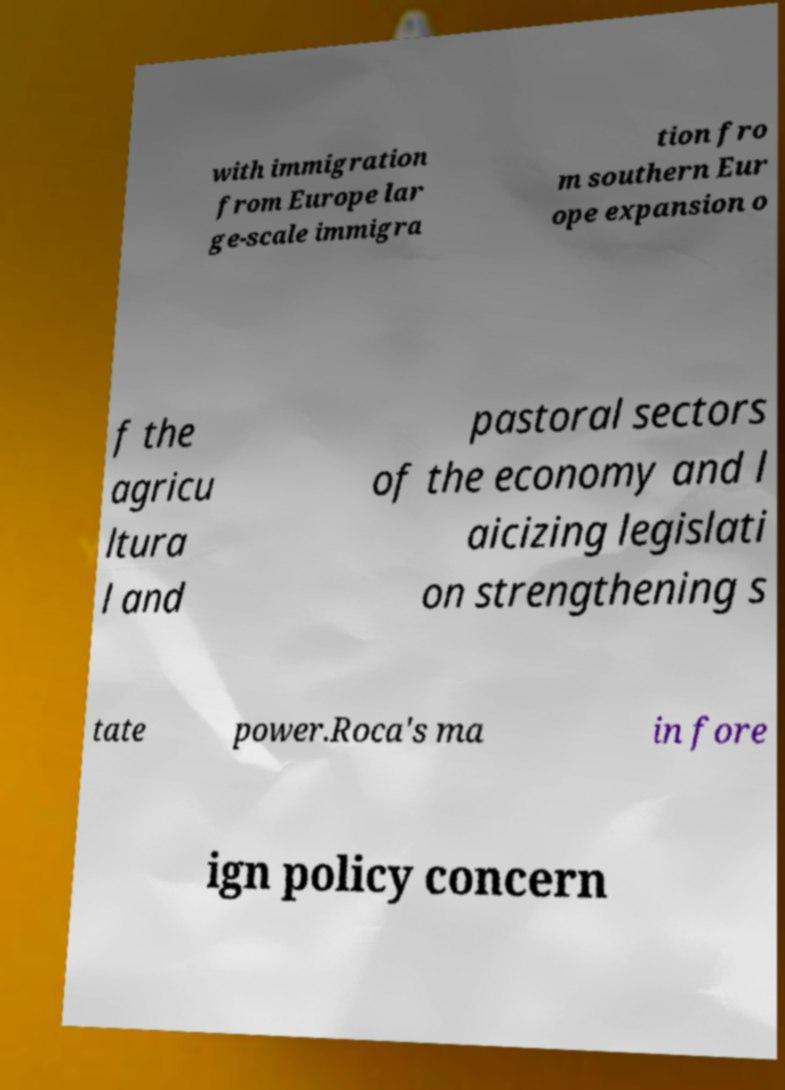Can you read and provide the text displayed in the image?This photo seems to have some interesting text. Can you extract and type it out for me? with immigration from Europe lar ge-scale immigra tion fro m southern Eur ope expansion o f the agricu ltura l and pastoral sectors of the economy and l aicizing legislati on strengthening s tate power.Roca's ma in fore ign policy concern 